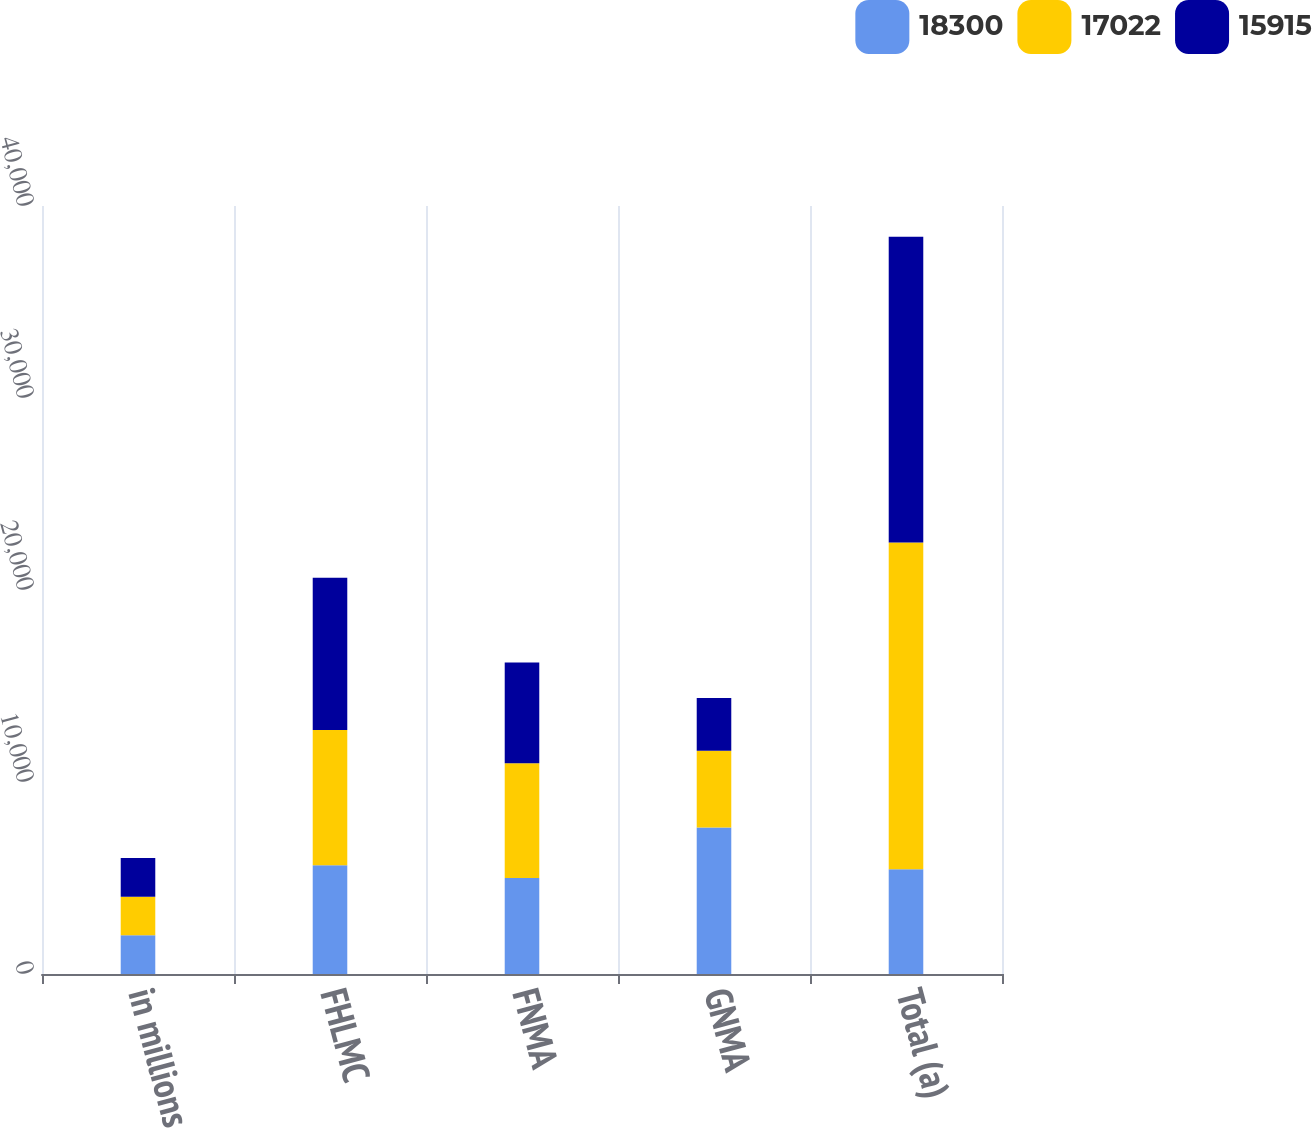Convert chart to OTSL. <chart><loc_0><loc_0><loc_500><loc_500><stacked_bar_chart><ecel><fcel>in millions<fcel>FHLMC<fcel>FNMA<fcel>GNMA<fcel>Total (a)<nl><fcel>18300<fcel>2014<fcel>5666<fcel>4998<fcel>7636<fcel>5456<nl><fcel>17022<fcel>2013<fcel>7047<fcel>5978<fcel>3997<fcel>17022<nl><fcel>15915<fcel>2012<fcel>7923<fcel>5246<fcel>2746<fcel>15915<nl></chart> 